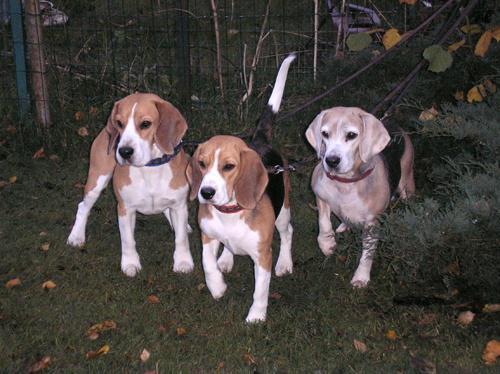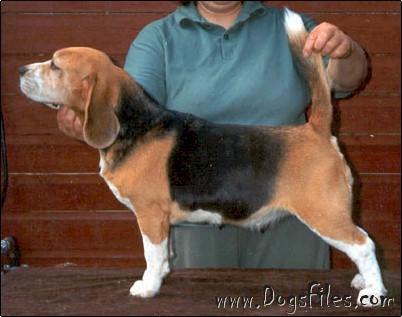The first image is the image on the left, the second image is the image on the right. Considering the images on both sides, is "A person is behind a standing beagle, holding the base of its tail upward with one hand and propping its chin with the other." valid? Answer yes or no. Yes. The first image is the image on the left, the second image is the image on the right. For the images displayed, is the sentence "A human is touching a dogs tail in the right image." factually correct? Answer yes or no. Yes. 